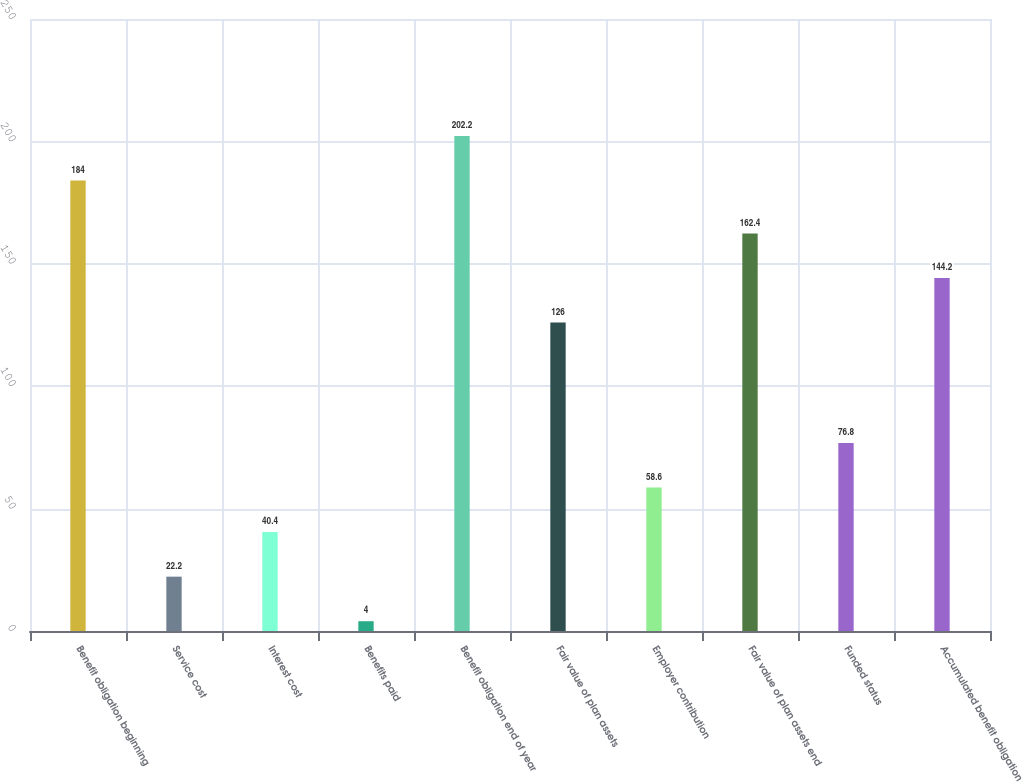<chart> <loc_0><loc_0><loc_500><loc_500><bar_chart><fcel>Benefit obligation beginning<fcel>Service cost<fcel>Interest cost<fcel>Benefits paid<fcel>Benefit obligation end of year<fcel>Fair value of plan assets<fcel>Employer contribution<fcel>Fair value of plan assets end<fcel>Funded status<fcel>Accumulated benefit obligation<nl><fcel>184<fcel>22.2<fcel>40.4<fcel>4<fcel>202.2<fcel>126<fcel>58.6<fcel>162.4<fcel>76.8<fcel>144.2<nl></chart> 